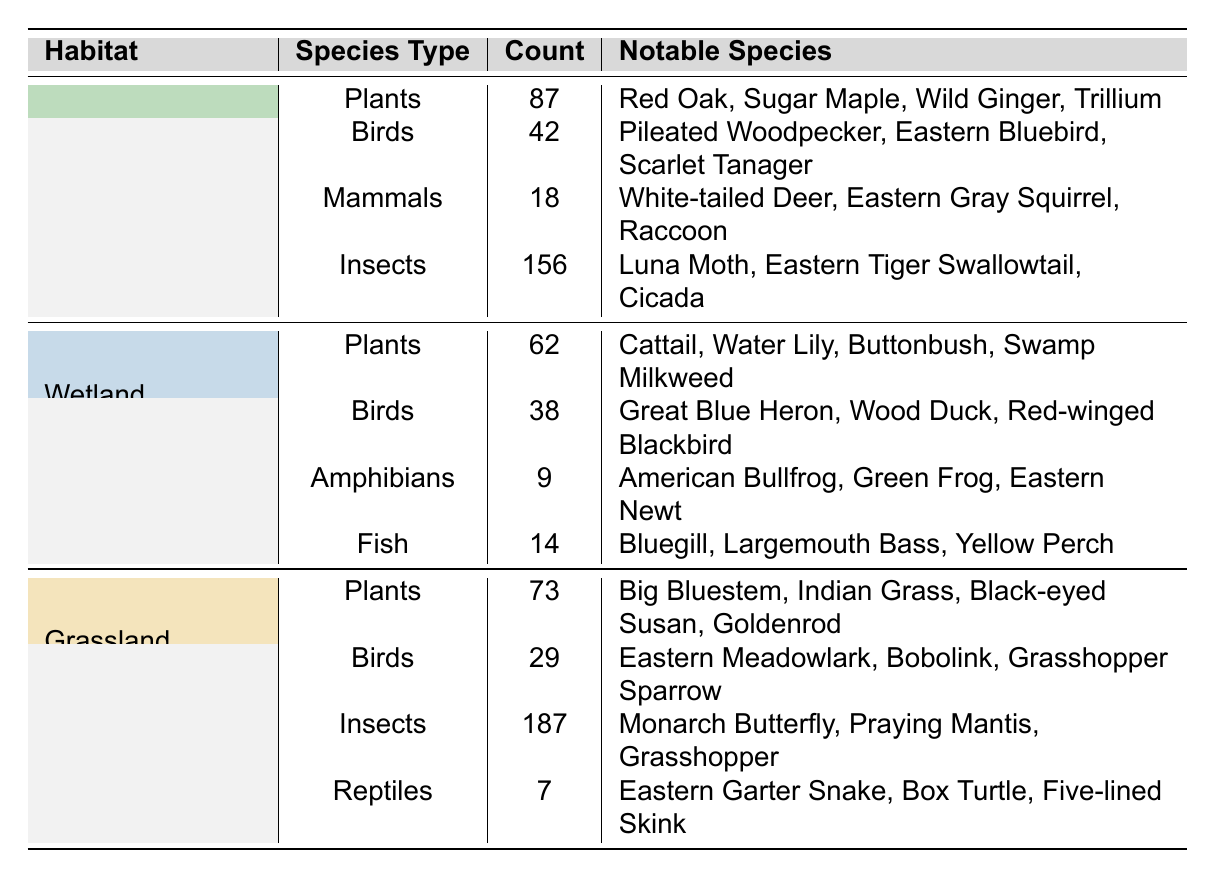What is the total number of bird species observed in the Deciduous Forest habitat? The table lists the birds in the Deciduous Forest as having a count of 42. Therefore, the total number of bird species observed is simply that count.
Answer: 42 How many mammal species are recorded in the Wetland habitat? According to the table, the Wetland habitat has a record of 0 mammal species, as there are no entries under mammals for that habitat.
Answer: 0 Which habitat has the highest number of insect species? By comparing the insect counts across all three habitats, we see that the Grassland has 187 insects, the Deciduous Forest has 156, and the Wetland has 0. Grassland has the highest count.
Answer: Grassland What is the combined total number of plant species in all habitats? Adding the counts of plants across all habitats: 87 (Deciduous Forest) + 62 (Wetland) + 73 (Grassland) = 222 total plant species.
Answer: 222 Is the number of amphibian species in Wetland greater than the number of reptile species in Grassland? The Wetland has 9 amphibian species, while Grassland has 7 reptile species. Since 9 is greater than 7, the statement is true.
Answer: Yes Which habitat has the fewest notable species of mammals? The table shows that only the Deciduous Forest has notable mammal species with 18, while Wetland has 0 and Grassland has 0 notable mammals. Therefore, Wetland and Grassland tie for having the fewest at 0.
Answer: Wetland and Grassland How many species types are recorded in the Grassland habitat? The Grassland habitat features four species types: Plants, Birds, Insects, and Reptiles. Therefore, we conclude there are four recorded types.
Answer: 4 What is the difference in the number of bird species between the Deciduous Forest and the Grassland? The Deciduous Forest contains 42 bird species while the Grassland has 29. The difference is 42 - 29 = 13 species.
Answer: 13 Which notable species is common to both the Wetland and Grassland habitats? After reviewing the notable species, there are no species listed that are common between the Wetland and Grassland habitats; each is unique in its notable species.
Answer: No What is the average number of species types across all three habitats? Each habitat features 4 types of species. Therefore, the average is calculated as (4 + 4 + 4) / 3 = 4.
Answer: 4 